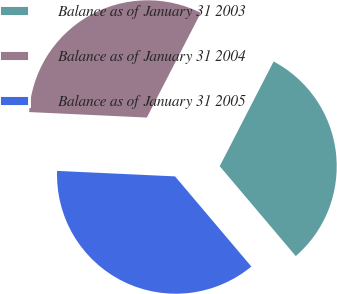Convert chart to OTSL. <chart><loc_0><loc_0><loc_500><loc_500><pie_chart><fcel>Balance as of January 31 2003<fcel>Balance as of January 31 2004<fcel>Balance as of January 31 2005<nl><fcel>31.26%<fcel>31.83%<fcel>36.92%<nl></chart> 